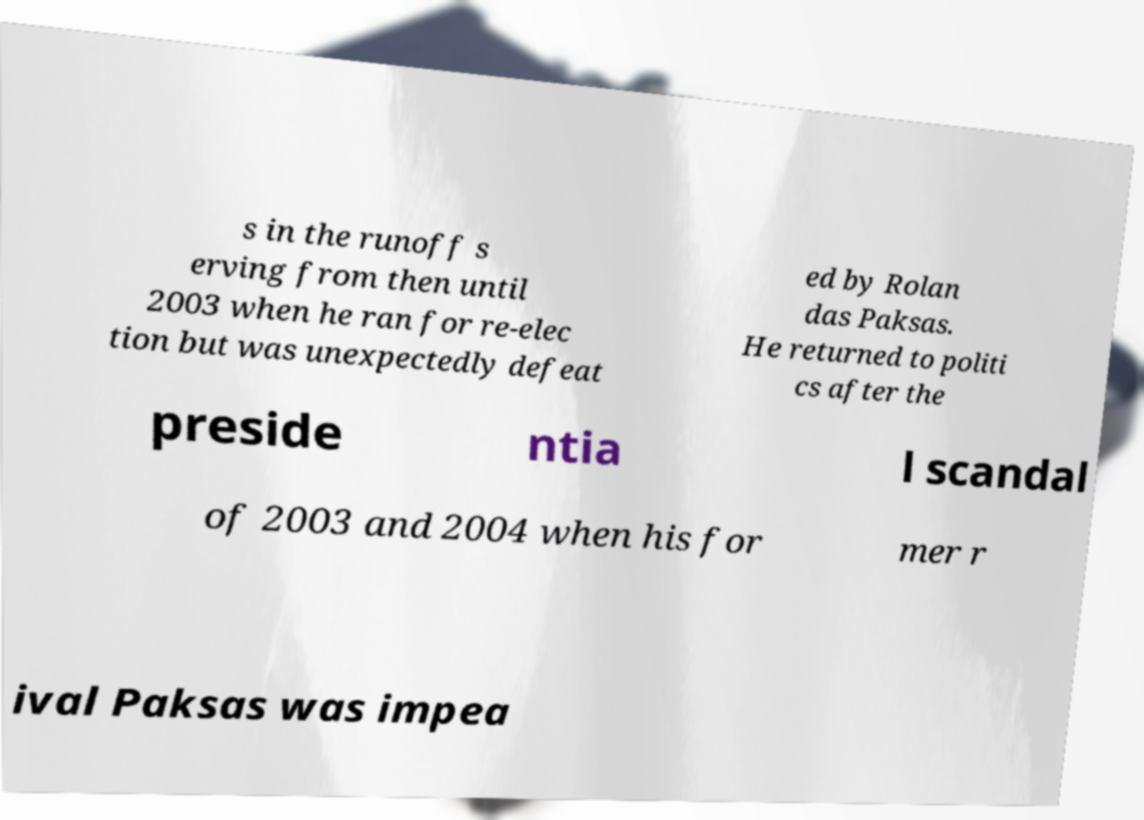Please read and relay the text visible in this image. What does it say? s in the runoff s erving from then until 2003 when he ran for re-elec tion but was unexpectedly defeat ed by Rolan das Paksas. He returned to politi cs after the preside ntia l scandal of 2003 and 2004 when his for mer r ival Paksas was impea 